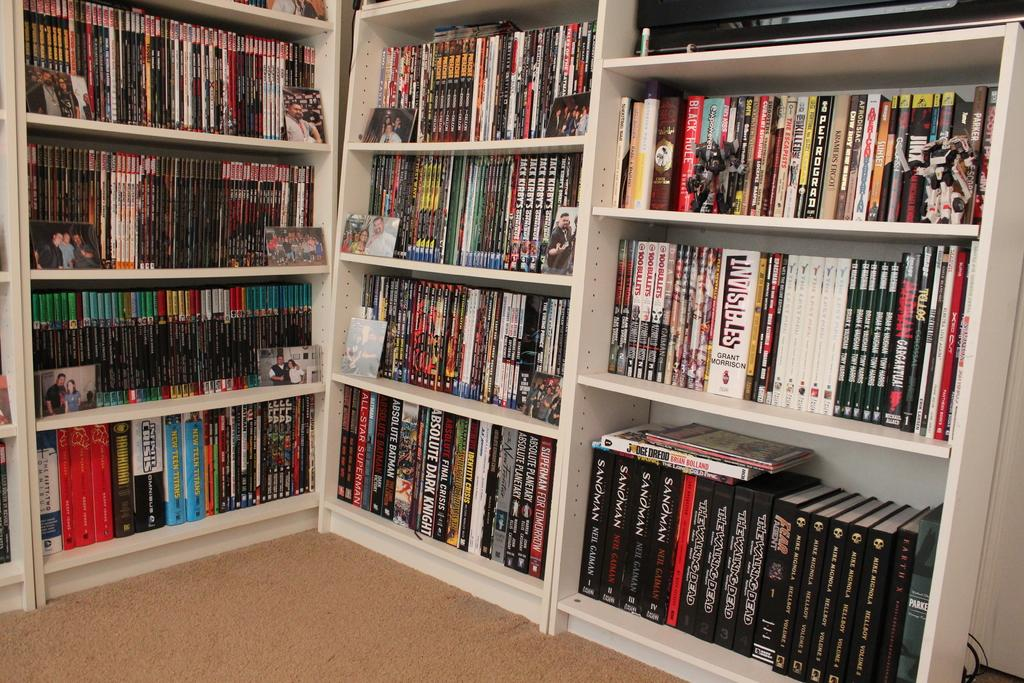Provide a one-sentence caption for the provided image. Bookshelves containg many books some are written by Neil Gaiman. 